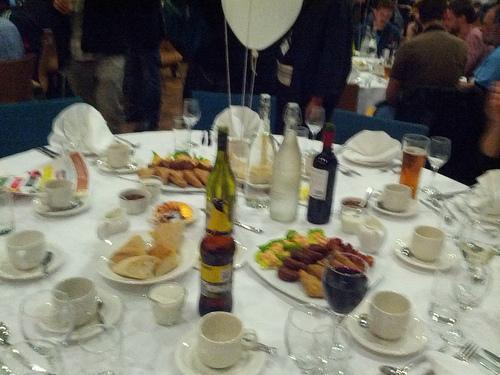How many green bottles are on this table?
Give a very brief answer. 1. 